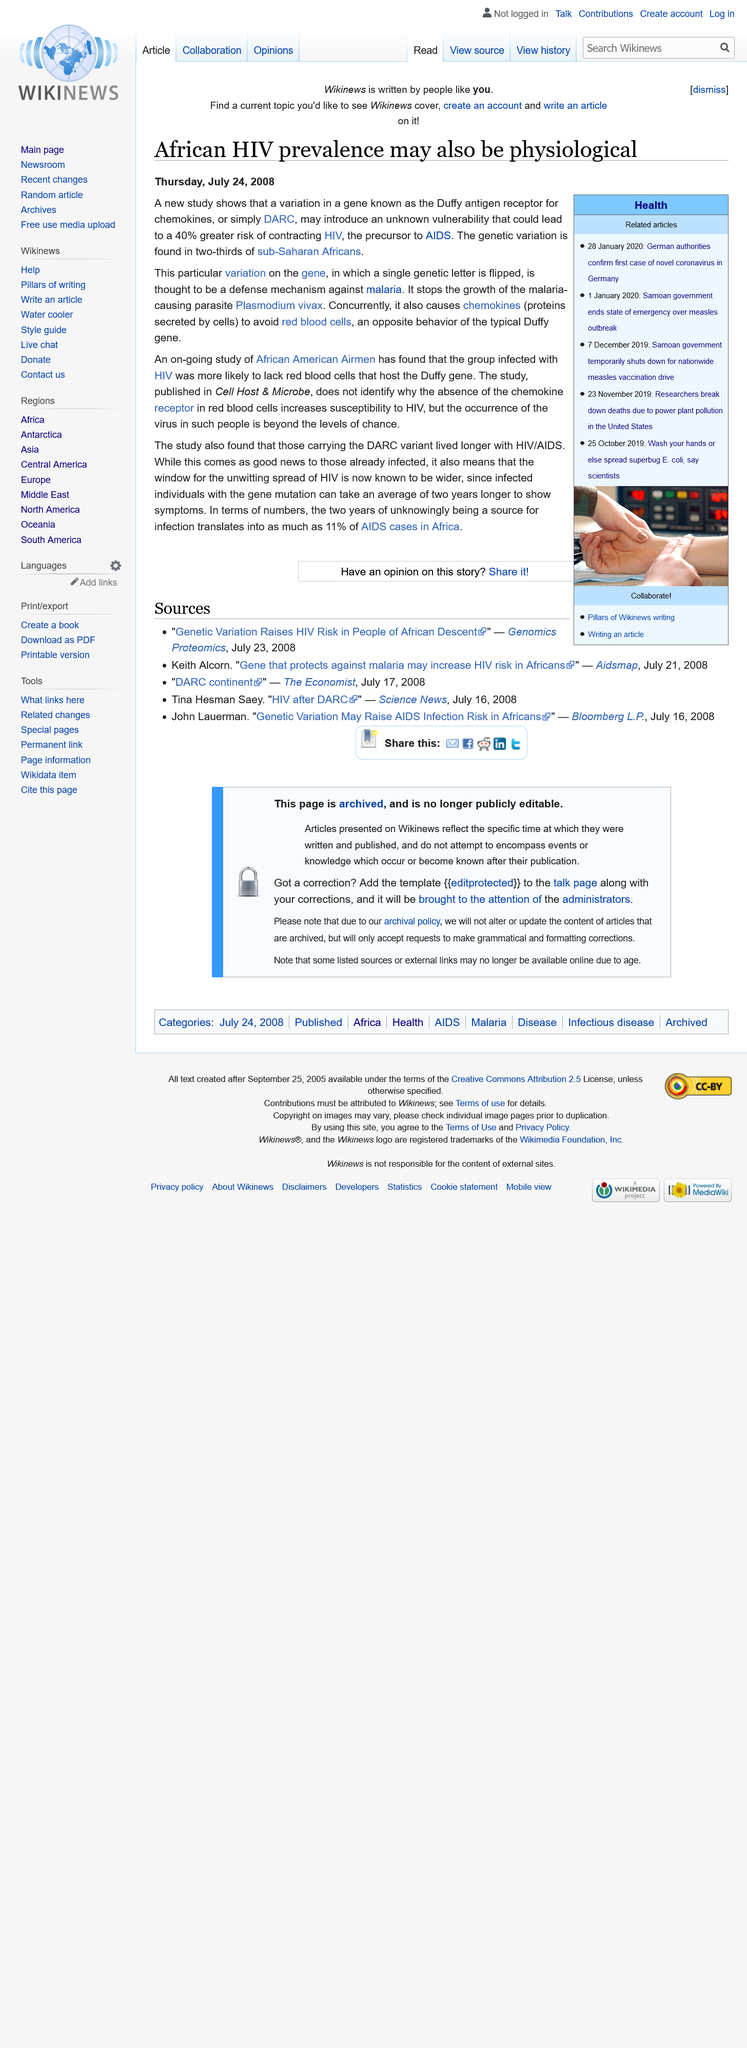Indicate a few pertinent items in this graphic. July 24th 2008 was the date on which this article was published. A specific gene variation, known as the Duffy antigen receptor for chemokines, or DARC, has been found to potentially create an unknown vulnerability that could increase the likelihood of contracting HIV by 40%. This discovery highlights the complex and nuanced nature of genetic influences on disease risk and underscores the importance of continued research in this area. The gene variation known as DARC is believed to provide protection against malaria. Malaria is a disease that is caused by the parasite Plasmodium and is transmitted through the bite of infected mosquitoes. Studies have shown that individuals with the DARC gene variation have a reduced risk of contracting malaria, suggesting that this gene may play a role in defending against the disease. 